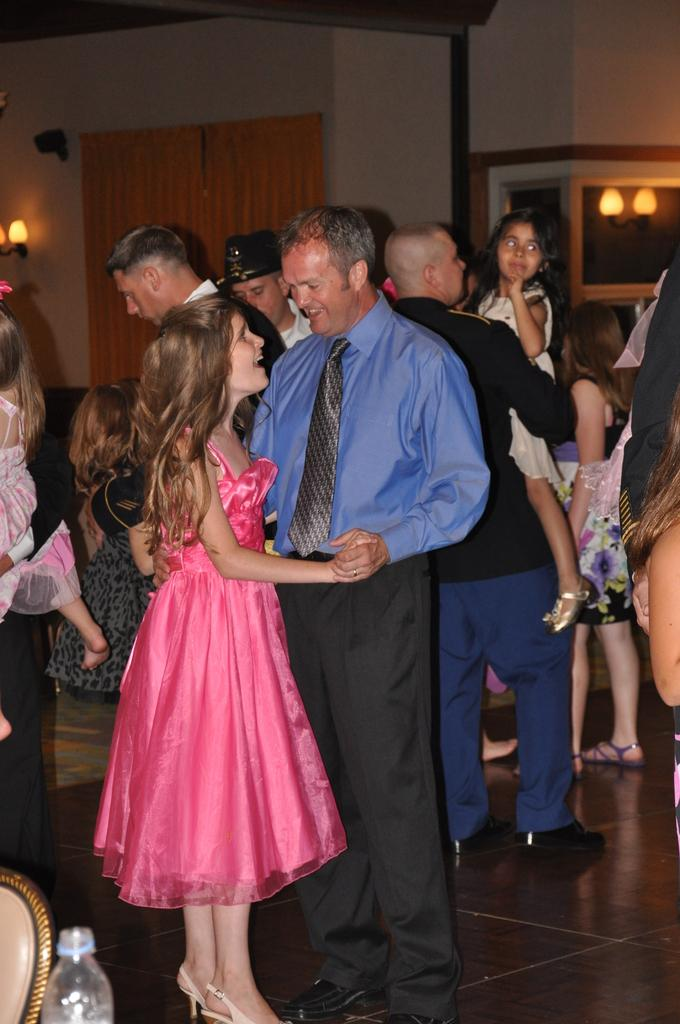What can be seen in the image? There are people standing in the image. What is visible in the background of the image? There is a wall in the background of the image. What features are present on the wall? There are lights on the wall. Is there any window treatment associated with the wall? Yes, there is a curtain associated with the wall. What type of education is being provided to the babies in the image? There are no babies present in the image, and therefore no education is being provided. 